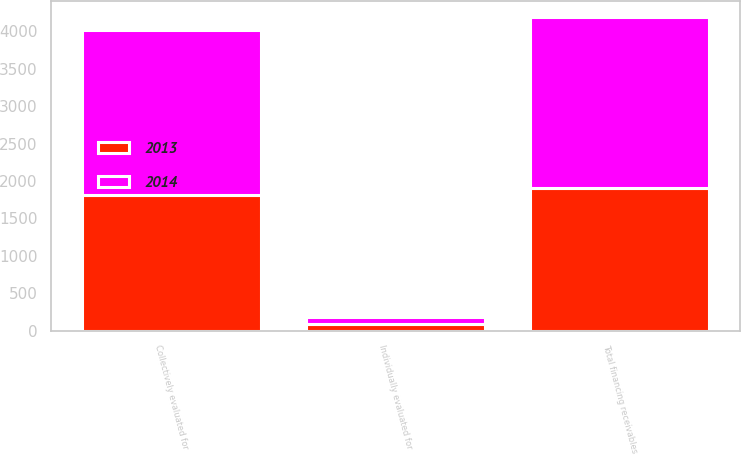Convert chart to OTSL. <chart><loc_0><loc_0><loc_500><loc_500><stacked_bar_chart><ecel><fcel>Individually evaluated for<fcel>Collectively evaluated for<fcel>Total financing receivables<nl><fcel>2013<fcel>86<fcel>1819<fcel>1905<nl><fcel>2014<fcel>95<fcel>2191<fcel>2286<nl></chart> 